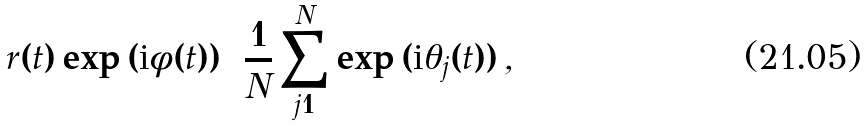<formula> <loc_0><loc_0><loc_500><loc_500>r ( t ) \exp { ( { \mbox i } \phi ( t ) ) } = \frac { 1 } { N } \sum _ { j = 1 } ^ { N } \exp { ( { \mbox i } \theta _ { j } ( t ) ) } \, ,</formula> 